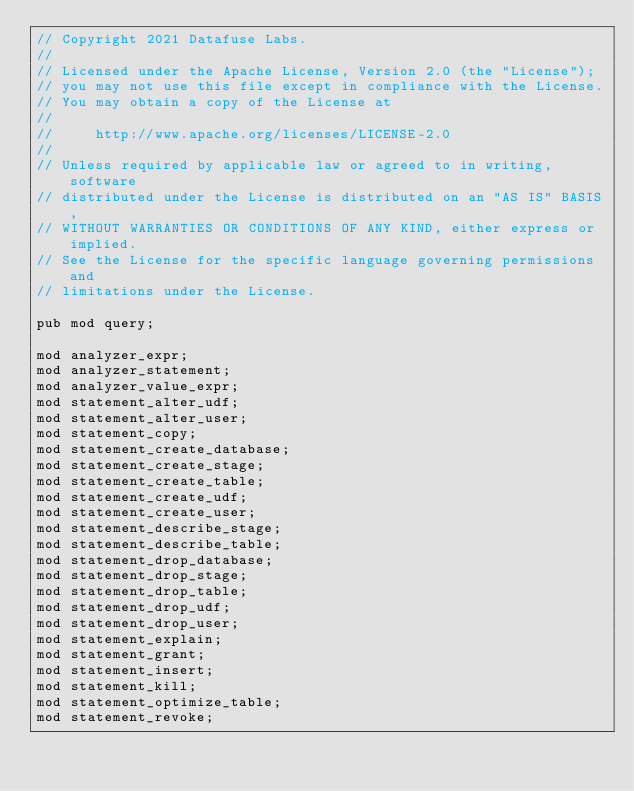Convert code to text. <code><loc_0><loc_0><loc_500><loc_500><_Rust_>// Copyright 2021 Datafuse Labs.
//
// Licensed under the Apache License, Version 2.0 (the "License");
// you may not use this file except in compliance with the License.
// You may obtain a copy of the License at
//
//     http://www.apache.org/licenses/LICENSE-2.0
//
// Unless required by applicable law or agreed to in writing, software
// distributed under the License is distributed on an "AS IS" BASIS,
// WITHOUT WARRANTIES OR CONDITIONS OF ANY KIND, either express or implied.
// See the License for the specific language governing permissions and
// limitations under the License.

pub mod query;

mod analyzer_expr;
mod analyzer_statement;
mod analyzer_value_expr;
mod statement_alter_udf;
mod statement_alter_user;
mod statement_copy;
mod statement_create_database;
mod statement_create_stage;
mod statement_create_table;
mod statement_create_udf;
mod statement_create_user;
mod statement_describe_stage;
mod statement_describe_table;
mod statement_drop_database;
mod statement_drop_stage;
mod statement_drop_table;
mod statement_drop_udf;
mod statement_drop_user;
mod statement_explain;
mod statement_grant;
mod statement_insert;
mod statement_kill;
mod statement_optimize_table;
mod statement_revoke;</code> 